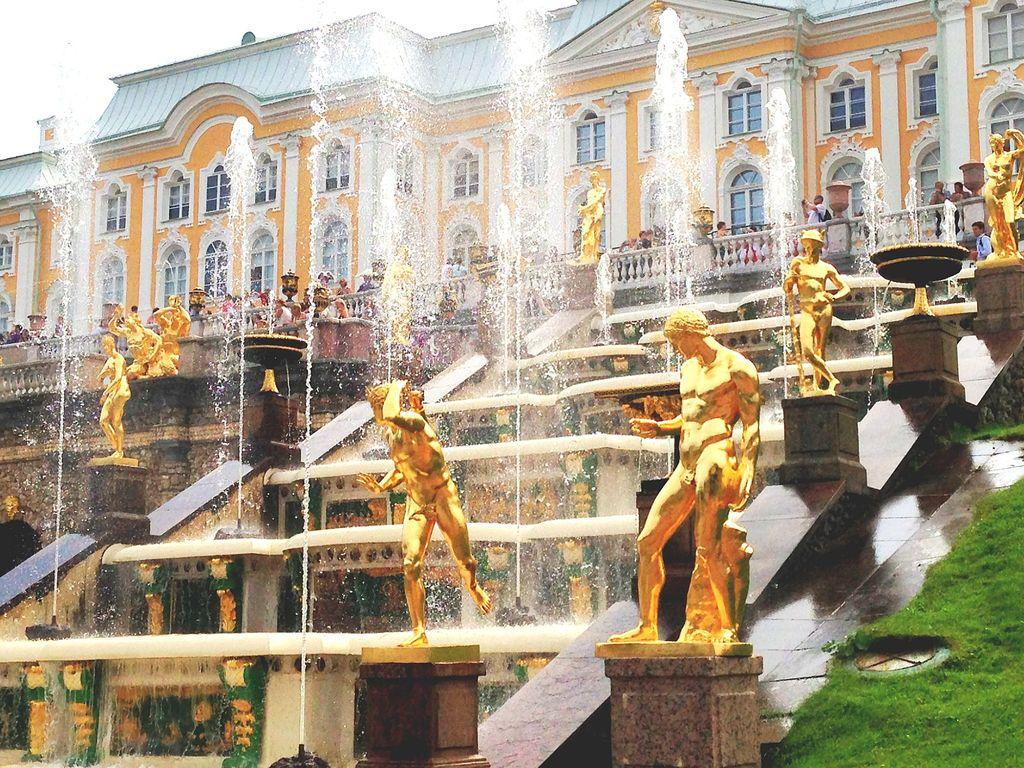What type of water feature can be seen in the image? There are water fountains in the image. What type of artwork is present in the image? There are sculptures of people in the image. Can you describe the people in the image? There is a group of people in the image. What type of structure is visible in the image? There is a building in the image. What type of vegetation is present in the image? There is grass in the image. What can be seen in the background of the image? The sky is visible in the background of the image. How many strings are attached to the flock of birds in the image? There are no birds or strings present in the image. What type of flame can be seen coming from the sculpture in the image? There is no flame present in the image; it features water fountains and sculptures of people. 